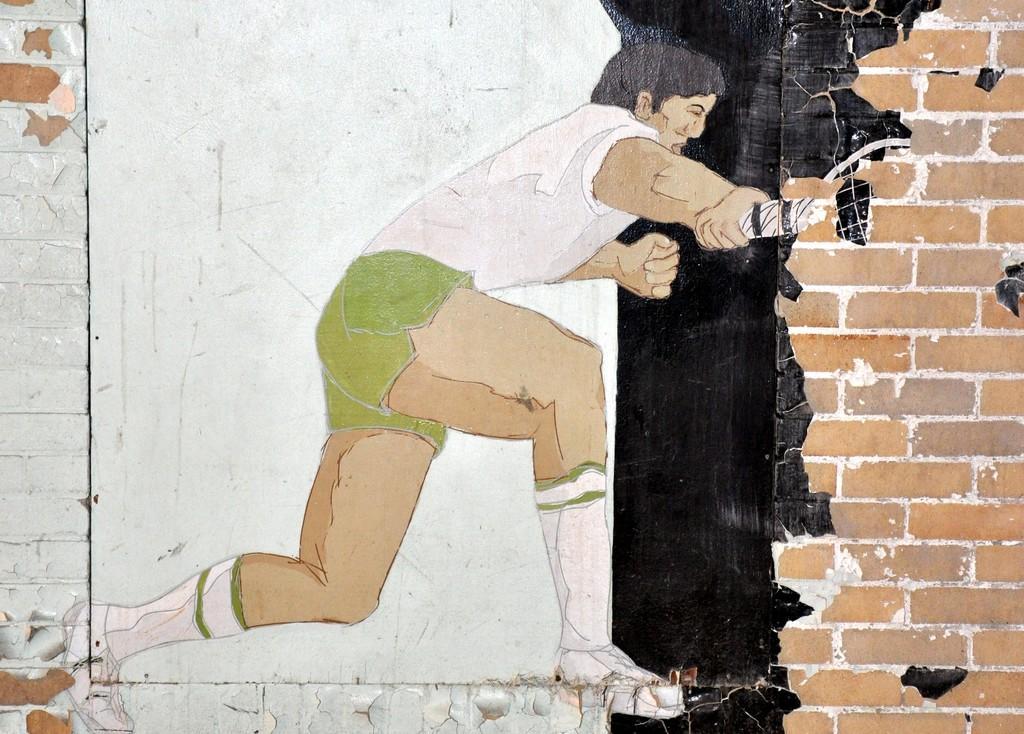Describe this image in one or two sentences. In this image there is a painting of a boy holding some object on the wall. 